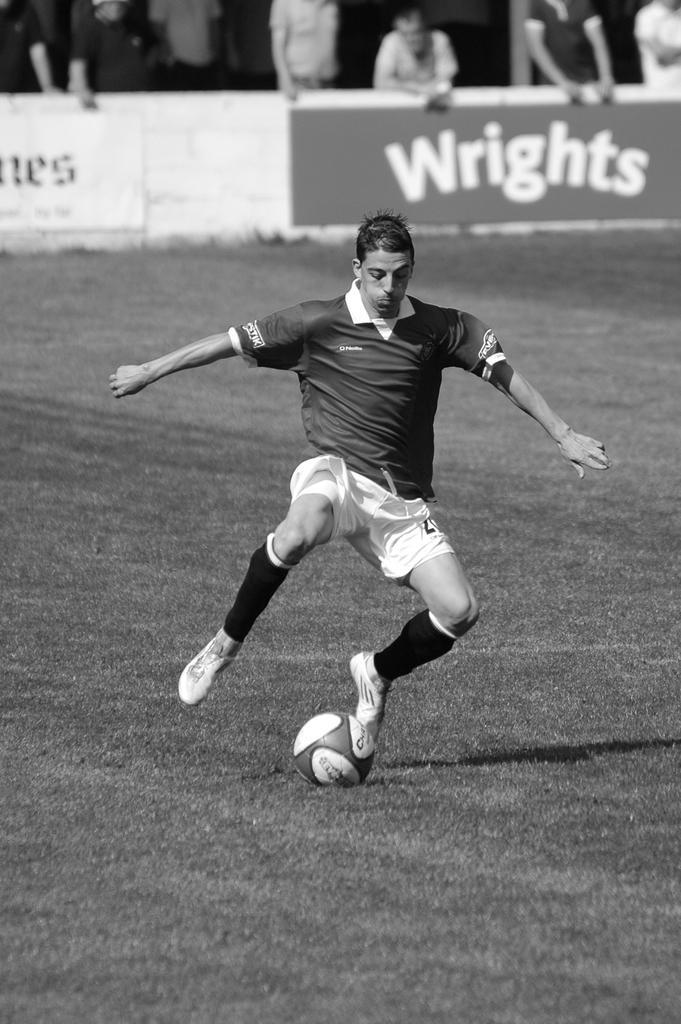In one or two sentences, can you explain what this image depicts? This is a black and white image. This picture is taken inside the playground. In this image, in the middle, we can see a man playing a football. In the background, we can see some hoardings, a group of people. At the bottom, we can see a football which is placed on the grass. 